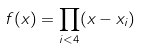<formula> <loc_0><loc_0><loc_500><loc_500>f ( x ) = \prod _ { i < 4 } ( x - x _ { i } )</formula> 